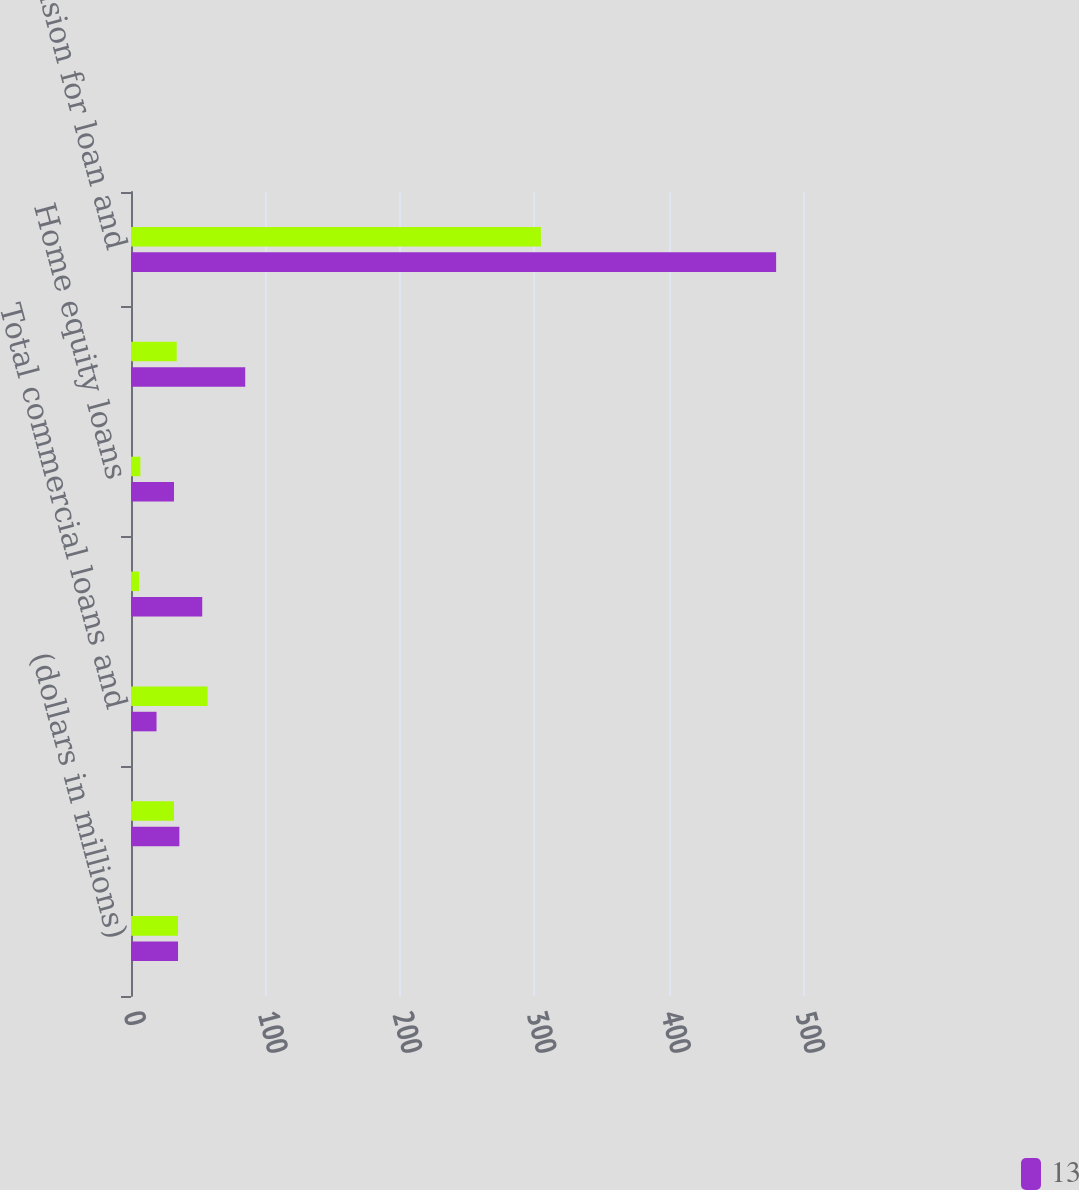<chart> <loc_0><loc_0><loc_500><loc_500><stacked_bar_chart><ecel><fcel>(dollars in millions)<fcel>Commercial real estate<fcel>Total commercial loans and<fcel>Residential mortgages<fcel>Home equity loans<fcel>Home equity lines of credit<fcel>Total provision for loan and<nl><fcel>nan<fcel>35<fcel>32<fcel>57<fcel>6<fcel>7<fcel>34<fcel>305<nl><fcel>13<fcel>35<fcel>36<fcel>19<fcel>53<fcel>32<fcel>85<fcel>480<nl></chart> 